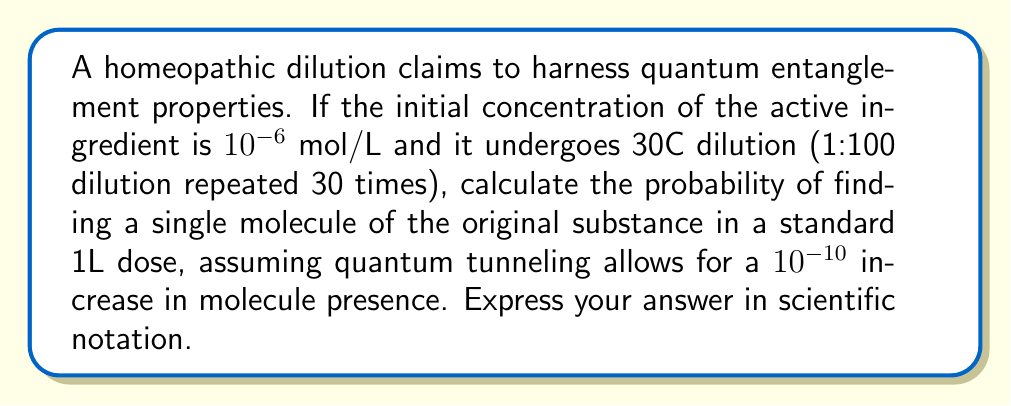Can you answer this question? 1) First, calculate the dilution factor:
   $$(1/100)^{30} = 10^{-60}$$

2) Calculate the concentration after dilution:
   $$10^{-6} \times 10^{-60} = 10^{-66} \text{ mol/L}$$

3) Convert to molecules per liter using Avogadro's number:
   $$10^{-66} \times 6.022 \times 10^{23} \approx 6.022 \times 10^{-43} \text{ molecules/L}$$

4) Account for quantum tunneling:
   $$6.022 \times 10^{-43} \times (1 + 10^{-10}) \approx 6.022 \times 10^{-43} \text{ molecules/L}$$

5) This represents the probability of finding a single molecule in 1L.
Answer: $6.022 \times 10^{-43}$ 